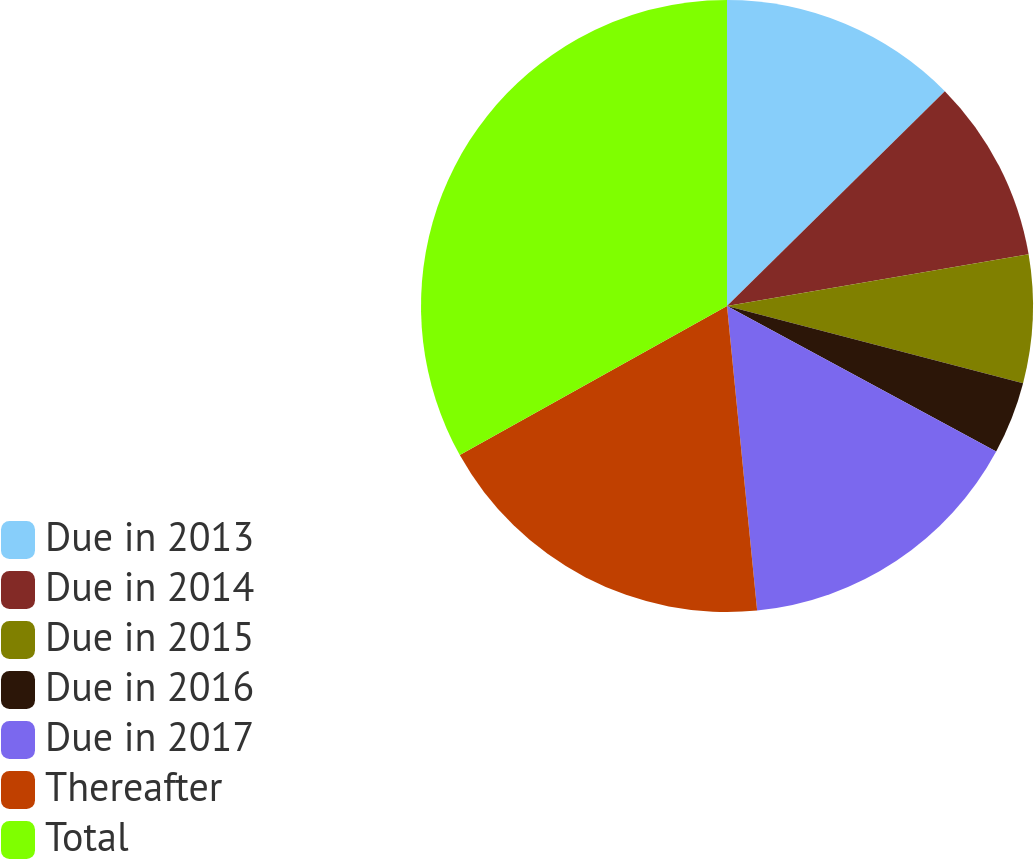Convert chart to OTSL. <chart><loc_0><loc_0><loc_500><loc_500><pie_chart><fcel>Due in 2013<fcel>Due in 2014<fcel>Due in 2015<fcel>Due in 2016<fcel>Due in 2017<fcel>Thereafter<fcel>Total<nl><fcel>12.61%<fcel>9.69%<fcel>6.76%<fcel>3.83%<fcel>15.54%<fcel>18.47%<fcel>33.1%<nl></chart> 